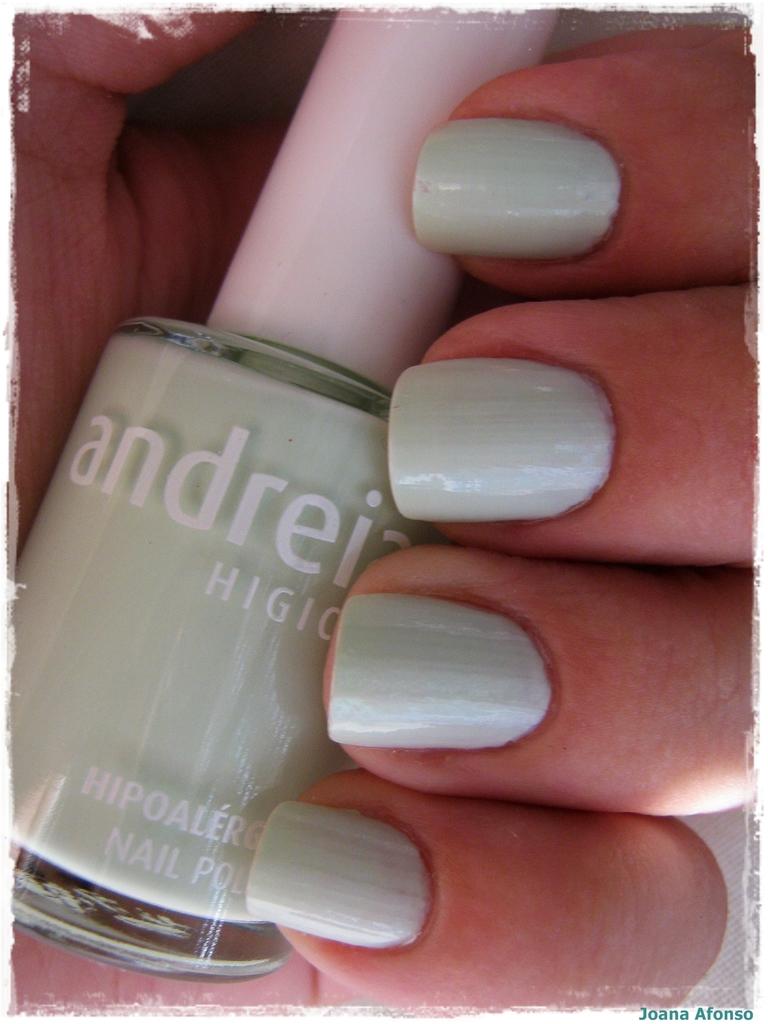What is the name of the nail polish?
Give a very brief answer. Andreia. 